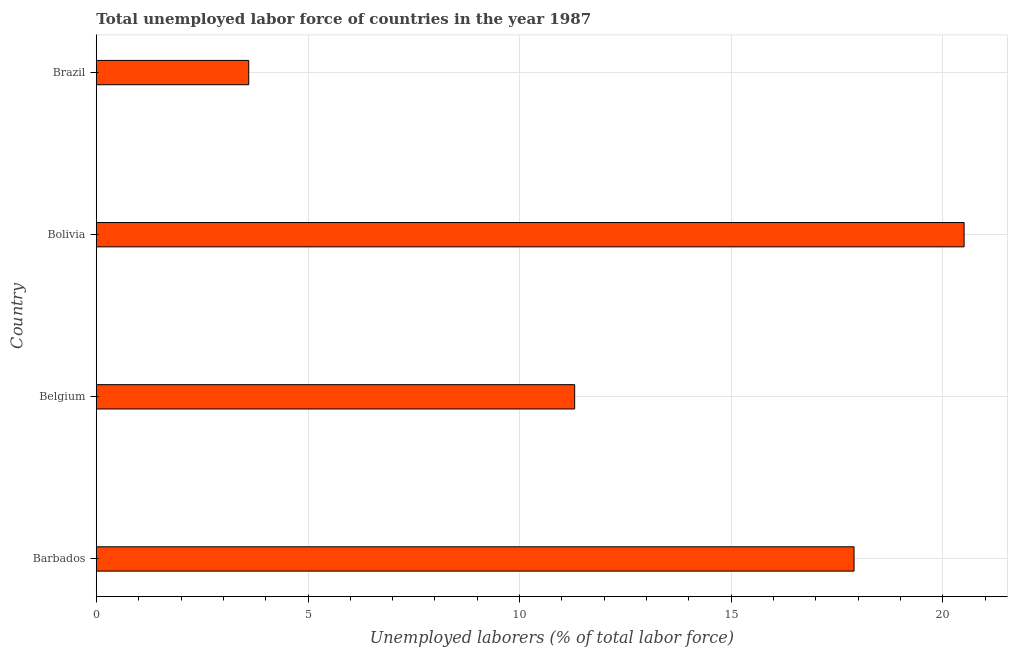What is the title of the graph?
Provide a short and direct response. Total unemployed labor force of countries in the year 1987. What is the label or title of the X-axis?
Your answer should be compact. Unemployed laborers (% of total labor force). What is the total unemployed labour force in Barbados?
Ensure brevity in your answer.  17.9. Across all countries, what is the maximum total unemployed labour force?
Provide a short and direct response. 20.5. Across all countries, what is the minimum total unemployed labour force?
Ensure brevity in your answer.  3.6. In which country was the total unemployed labour force maximum?
Provide a short and direct response. Bolivia. In which country was the total unemployed labour force minimum?
Offer a very short reply. Brazil. What is the sum of the total unemployed labour force?
Provide a short and direct response. 53.3. What is the average total unemployed labour force per country?
Give a very brief answer. 13.32. What is the median total unemployed labour force?
Your response must be concise. 14.6. In how many countries, is the total unemployed labour force greater than 15 %?
Keep it short and to the point. 2. What is the ratio of the total unemployed labour force in Belgium to that in Brazil?
Make the answer very short. 3.14. Is the total unemployed labour force in Belgium less than that in Bolivia?
Make the answer very short. Yes. What is the difference between the highest and the second highest total unemployed labour force?
Offer a very short reply. 2.6. Is the sum of the total unemployed labour force in Barbados and Bolivia greater than the maximum total unemployed labour force across all countries?
Your response must be concise. Yes. What is the difference between the highest and the lowest total unemployed labour force?
Keep it short and to the point. 16.9. In how many countries, is the total unemployed labour force greater than the average total unemployed labour force taken over all countries?
Give a very brief answer. 2. What is the difference between two consecutive major ticks on the X-axis?
Give a very brief answer. 5. What is the Unemployed laborers (% of total labor force) of Barbados?
Offer a very short reply. 17.9. What is the Unemployed laborers (% of total labor force) of Belgium?
Make the answer very short. 11.3. What is the Unemployed laborers (% of total labor force) of Brazil?
Provide a succinct answer. 3.6. What is the difference between the Unemployed laborers (% of total labor force) in Barbados and Bolivia?
Keep it short and to the point. -2.6. What is the difference between the Unemployed laborers (% of total labor force) in Belgium and Bolivia?
Give a very brief answer. -9.2. What is the difference between the Unemployed laborers (% of total labor force) in Belgium and Brazil?
Make the answer very short. 7.7. What is the difference between the Unemployed laborers (% of total labor force) in Bolivia and Brazil?
Your answer should be very brief. 16.9. What is the ratio of the Unemployed laborers (% of total labor force) in Barbados to that in Belgium?
Offer a very short reply. 1.58. What is the ratio of the Unemployed laborers (% of total labor force) in Barbados to that in Bolivia?
Give a very brief answer. 0.87. What is the ratio of the Unemployed laborers (% of total labor force) in Barbados to that in Brazil?
Provide a succinct answer. 4.97. What is the ratio of the Unemployed laborers (% of total labor force) in Belgium to that in Bolivia?
Provide a succinct answer. 0.55. What is the ratio of the Unemployed laborers (% of total labor force) in Belgium to that in Brazil?
Your answer should be compact. 3.14. What is the ratio of the Unemployed laborers (% of total labor force) in Bolivia to that in Brazil?
Give a very brief answer. 5.69. 